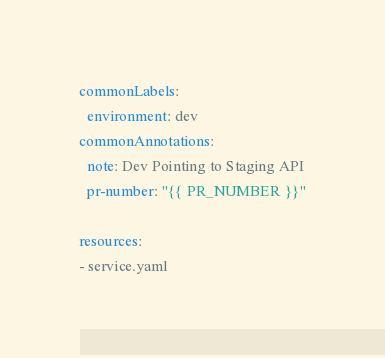Convert code to text. <code><loc_0><loc_0><loc_500><loc_500><_YAML_>commonLabels:
  environment: dev
commonAnnotations:
  note: Dev Pointing to Staging API
  pr-number: "{{ PR_NUMBER }}"

resources:
- service.yaml
</code> 